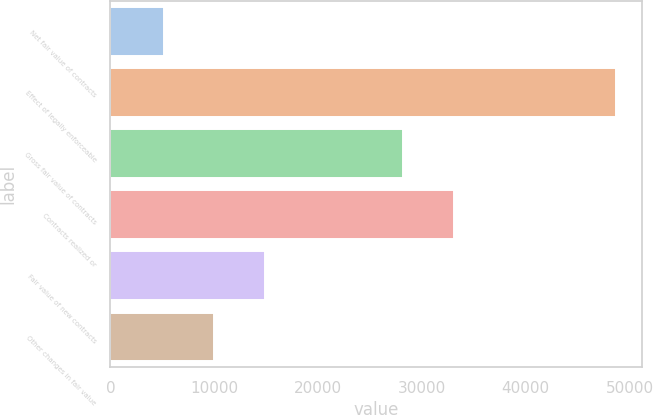Convert chart to OTSL. <chart><loc_0><loc_0><loc_500><loc_500><bar_chart><fcel>Net fair value of contracts<fcel>Effect of legally enforceable<fcel>Gross fair value of contracts<fcel>Contracts realized or<fcel>Fair value of new contracts<fcel>Other changes in fair value<nl><fcel>5139<fcel>48726<fcel>28227<fcel>33099.6<fcel>14884.2<fcel>10011.6<nl></chart> 